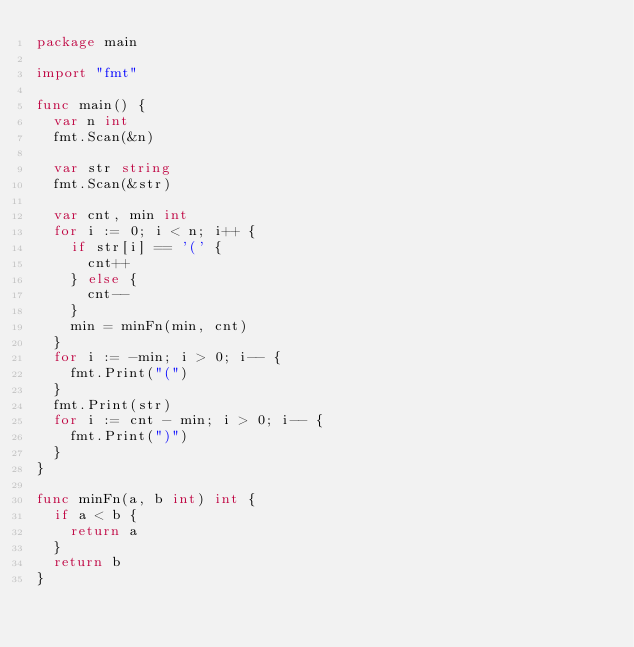Convert code to text. <code><loc_0><loc_0><loc_500><loc_500><_Go_>package main

import "fmt"

func main() {
	var n int
	fmt.Scan(&n)

	var str string
	fmt.Scan(&str)

	var cnt, min int
	for i := 0; i < n; i++ {
		if str[i] == '(' {
			cnt++
		} else {
			cnt--
		}
		min = minFn(min, cnt)
	}
	for i := -min; i > 0; i-- {
		fmt.Print("(")
	}
	fmt.Print(str)
	for i := cnt - min; i > 0; i-- {
		fmt.Print(")")
	}
}

func minFn(a, b int) int {
	if a < b {
		return a
	}
	return b
}</code> 